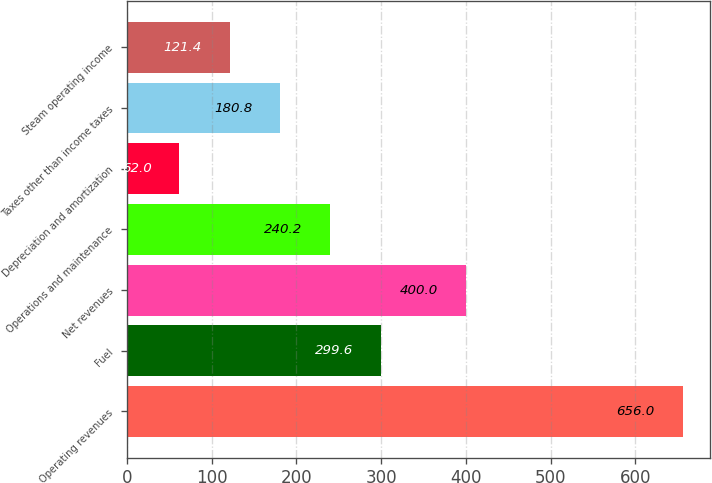<chart> <loc_0><loc_0><loc_500><loc_500><bar_chart><fcel>Operating revenues<fcel>Fuel<fcel>Net revenues<fcel>Operations and maintenance<fcel>Depreciation and amortization<fcel>Taxes other than income taxes<fcel>Steam operating income<nl><fcel>656<fcel>299.6<fcel>400<fcel>240.2<fcel>62<fcel>180.8<fcel>121.4<nl></chart> 